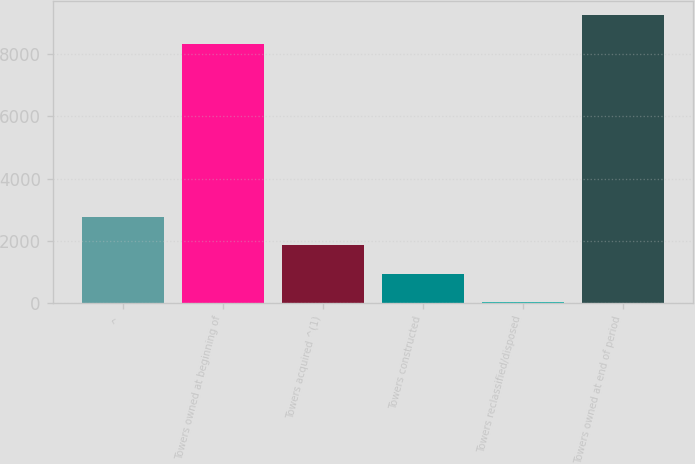Convert chart to OTSL. <chart><loc_0><loc_0><loc_500><loc_500><bar_chart><fcel>^<fcel>Towers owned at beginning of<fcel>Towers acquired ^(1)<fcel>Towers constructed<fcel>Towers reclassified/disposed<fcel>Towers owned at end of period<nl><fcel>2767.6<fcel>8324<fcel>1861.4<fcel>955.2<fcel>49<fcel>9230.2<nl></chart> 